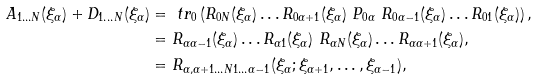<formula> <loc_0><loc_0><loc_500><loc_500>A _ { 1 \dots N } ( \xi _ { \alpha } ) + D _ { 1 \dots N } ( \xi _ { \alpha } ) & = \ t r _ { 0 } \left ( R _ { 0 N } ( \xi _ { \alpha } ) \dots R _ { 0 \alpha + 1 } ( \xi _ { \alpha } ) \ P _ { 0 \alpha } \ R _ { 0 \alpha - 1 } ( \xi _ { \alpha } ) \dots R _ { 0 1 } ( \xi _ { \alpha } ) \right ) , \\ & = R _ { \alpha \alpha - 1 } ( \xi _ { \alpha } ) \dots R _ { \alpha 1 } ( \xi _ { \alpha } ) \ R _ { \alpha N } ( \xi _ { \alpha } ) \dots R _ { \alpha \alpha + 1 } ( \xi _ { \alpha } ) , \\ & = R _ { \alpha , \alpha + 1 \dots N 1 \dots \alpha - 1 } ( \xi _ { \alpha } ; \xi _ { \alpha + 1 } , \dots , \xi _ { \alpha - 1 } ) ,</formula> 